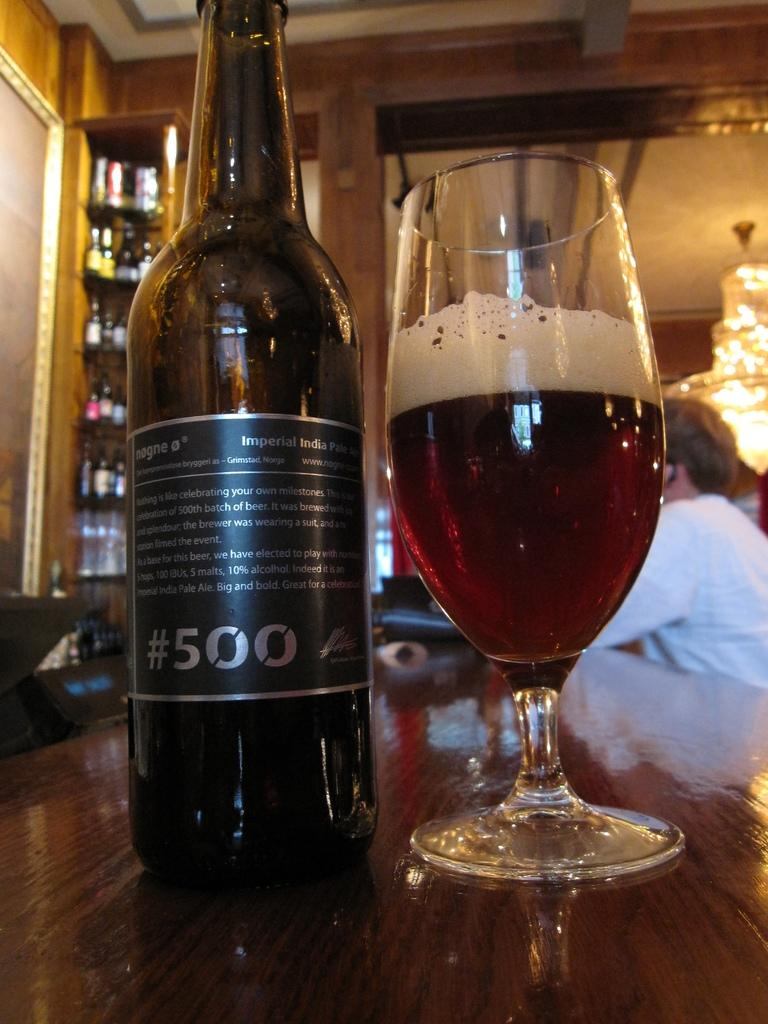What can be seen in the image that is used for holding liquids? There is a bottle and a glass with a drink in the image. Can you describe the contents of the glass? The glass contains a drink. What is visible in the background of the image? There is a person and additional bottles in the background of the image. What type of rake is being used to stir the drink in the glass? There is no rake present in the image, and the drink in the glass is not being stirred. Is there any smoke visible in the image? There is no smoke visible in the image. 